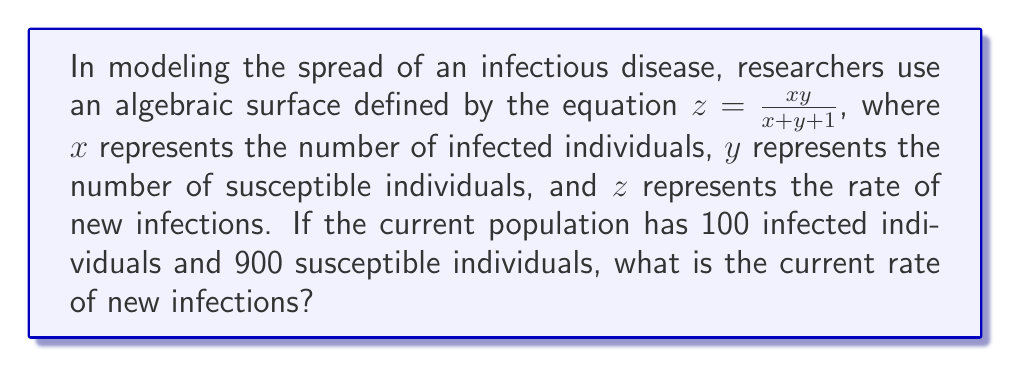Can you answer this question? To solve this problem, we'll follow these steps:

1. Identify the given information:
   - The algebraic surface is defined by $z = \frac{xy}{x+y+1}$
   - $x$ (infected individuals) = 100
   - $y$ (susceptible individuals) = 900

2. Substitute the values into the equation:
   $z = \frac{(100)(900)}{100+900+1}$

3. Simplify the numerator:
   $z = \frac{90,000}{1001}$

4. Perform the division:
   $z \approx 89.91$

The rate of new infections is approximately 89.91 individuals per unit time.

This algebraic surface model, known as a rational function, captures the interaction between infected and susceptible populations. It reflects the principle that the rate of new infections depends on both the number of infected individuals (who can spread the disease) and the number of susceptible individuals (who can become infected).
Answer: 89.91 